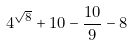<formula> <loc_0><loc_0><loc_500><loc_500>4 ^ { \sqrt { 8 } } + 1 0 - \frac { 1 0 } { 9 } - 8</formula> 